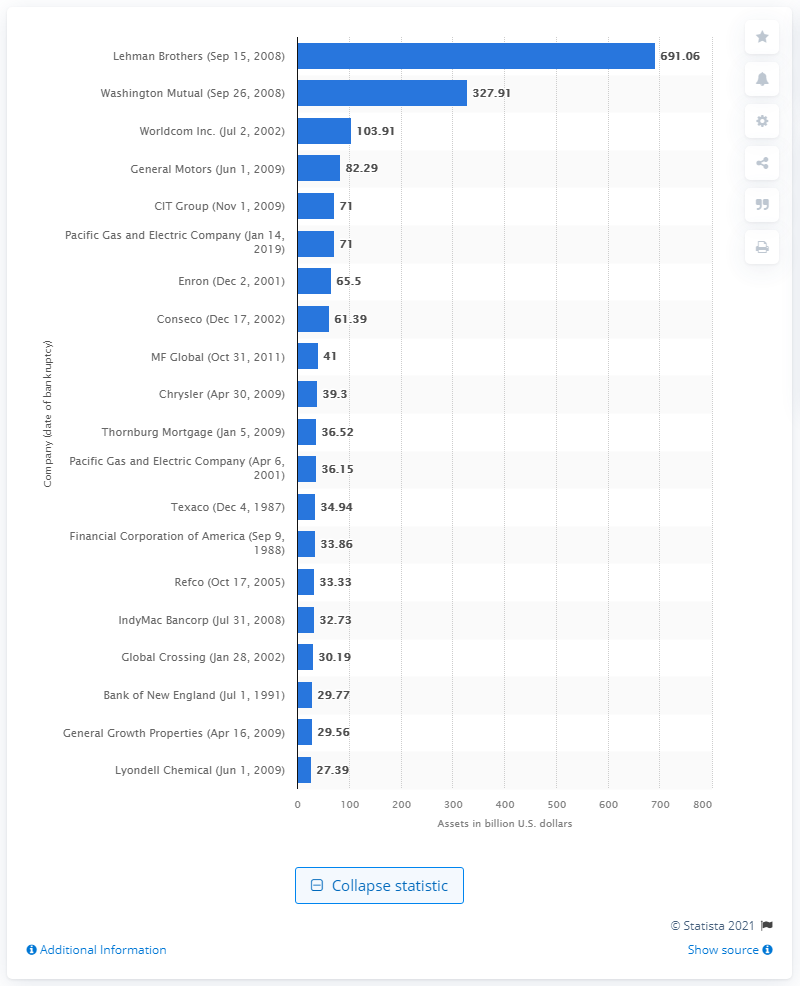Indicate a few pertinent items in this graphic. Lehman Brothers' assets were worth $691.06 million when it filed for bankruptcy. 